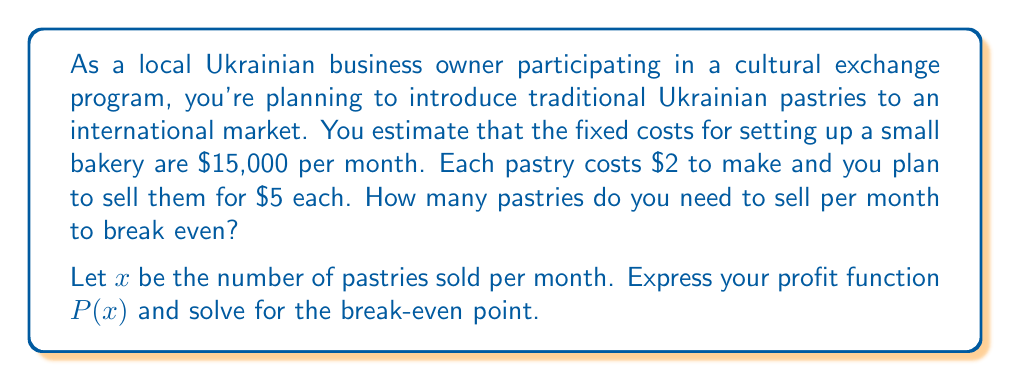Could you help me with this problem? To solve this problem, we need to follow these steps:

1. Define the profit function:
   Profit = Revenue - Total Costs
   $P(x) = \text{Revenue} - (\text{Fixed Costs} + \text{Variable Costs})$

2. Express each component in terms of $x$:
   Revenue = Price per pastry × Number of pastries sold
   $\text{Revenue} = 5x$

   Fixed Costs = $15,000 (given)

   Variable Costs = Cost per pastry × Number of pastries sold
   $\text{Variable Costs} = 2x$

3. Construct the profit function:
   $P(x) = 5x - (15000 + 2x)$
   $P(x) = 5x - 15000 - 2x$
   $P(x) = 3x - 15000$

4. To find the break-even point, set $P(x) = 0$ and solve for $x$:
   $0 = 3x - 15000$
   $15000 = 3x$
   $x = 5000$

Therefore, you need to sell 5,000 pastries per month to break even.

To verify:
Revenue = $5 × 5000 = $25,000
Total Costs = $15,000 + ($2 × 5000) = $25,000
Profit = $25,000 - $25,000 = $0

This confirms the break-even point.
Answer: The break-even point is 5,000 pastries per month. The profit function is $P(x) = 3x - 15000$. 